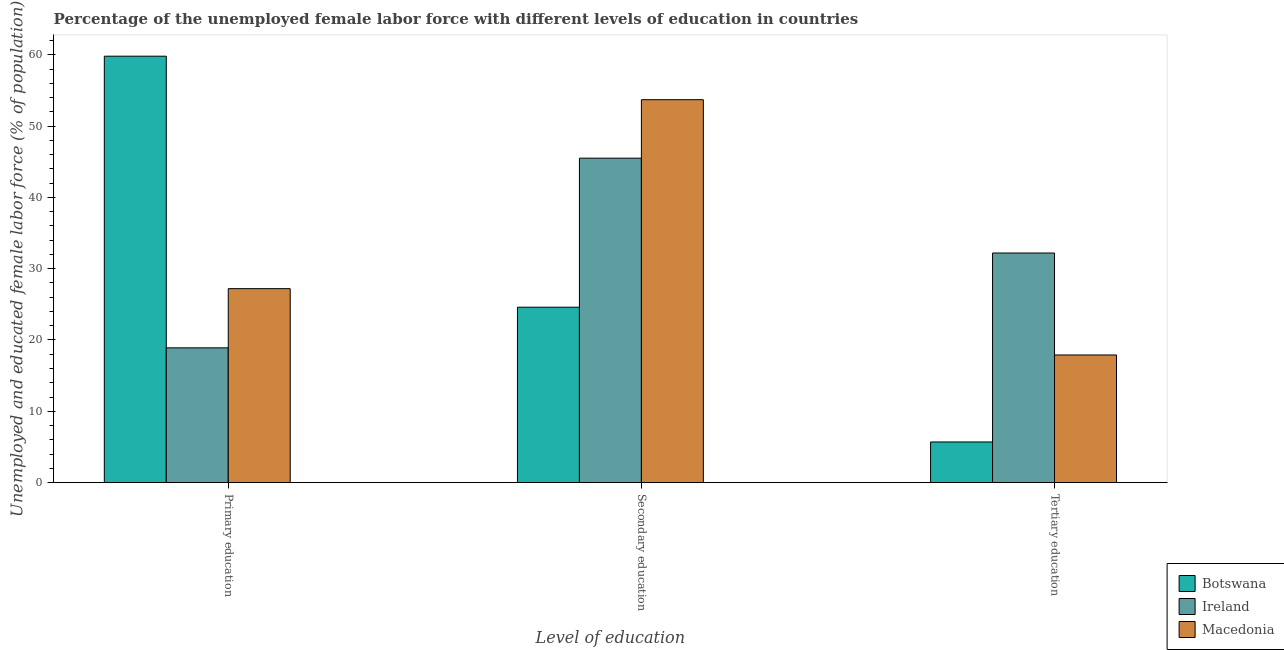How many different coloured bars are there?
Make the answer very short. 3. How many bars are there on the 3rd tick from the left?
Offer a very short reply. 3. How many bars are there on the 3rd tick from the right?
Ensure brevity in your answer.  3. What is the label of the 2nd group of bars from the left?
Offer a terse response. Secondary education. What is the percentage of female labor force who received tertiary education in Macedonia?
Ensure brevity in your answer.  17.9. Across all countries, what is the maximum percentage of female labor force who received tertiary education?
Your answer should be very brief. 32.2. Across all countries, what is the minimum percentage of female labor force who received secondary education?
Give a very brief answer. 24.6. In which country was the percentage of female labor force who received secondary education maximum?
Provide a short and direct response. Macedonia. In which country was the percentage of female labor force who received secondary education minimum?
Your answer should be compact. Botswana. What is the total percentage of female labor force who received tertiary education in the graph?
Provide a succinct answer. 55.8. What is the difference between the percentage of female labor force who received secondary education in Ireland and that in Botswana?
Make the answer very short. 20.9. What is the difference between the percentage of female labor force who received secondary education in Ireland and the percentage of female labor force who received primary education in Botswana?
Make the answer very short. -14.3. What is the average percentage of female labor force who received primary education per country?
Your response must be concise. 35.3. What is the difference between the percentage of female labor force who received primary education and percentage of female labor force who received secondary education in Botswana?
Your answer should be very brief. 35.2. What is the ratio of the percentage of female labor force who received tertiary education in Botswana to that in Ireland?
Your response must be concise. 0.18. Is the percentage of female labor force who received tertiary education in Macedonia less than that in Ireland?
Offer a terse response. Yes. Is the difference between the percentage of female labor force who received primary education in Ireland and Macedonia greater than the difference between the percentage of female labor force who received secondary education in Ireland and Macedonia?
Your answer should be very brief. No. What is the difference between the highest and the second highest percentage of female labor force who received secondary education?
Provide a short and direct response. 8.2. What is the difference between the highest and the lowest percentage of female labor force who received tertiary education?
Keep it short and to the point. 26.5. In how many countries, is the percentage of female labor force who received tertiary education greater than the average percentage of female labor force who received tertiary education taken over all countries?
Your answer should be very brief. 1. What does the 2nd bar from the left in Secondary education represents?
Provide a succinct answer. Ireland. What does the 1st bar from the right in Tertiary education represents?
Your answer should be very brief. Macedonia. Is it the case that in every country, the sum of the percentage of female labor force who received primary education and percentage of female labor force who received secondary education is greater than the percentage of female labor force who received tertiary education?
Give a very brief answer. Yes. How many bars are there?
Your answer should be compact. 9. How many countries are there in the graph?
Ensure brevity in your answer.  3. What is the difference between two consecutive major ticks on the Y-axis?
Make the answer very short. 10. Does the graph contain grids?
Provide a succinct answer. No. How many legend labels are there?
Offer a terse response. 3. What is the title of the graph?
Your answer should be very brief. Percentage of the unemployed female labor force with different levels of education in countries. What is the label or title of the X-axis?
Offer a terse response. Level of education. What is the label or title of the Y-axis?
Offer a very short reply. Unemployed and educated female labor force (% of population). What is the Unemployed and educated female labor force (% of population) in Botswana in Primary education?
Keep it short and to the point. 59.8. What is the Unemployed and educated female labor force (% of population) in Ireland in Primary education?
Keep it short and to the point. 18.9. What is the Unemployed and educated female labor force (% of population) in Macedonia in Primary education?
Ensure brevity in your answer.  27.2. What is the Unemployed and educated female labor force (% of population) of Botswana in Secondary education?
Ensure brevity in your answer.  24.6. What is the Unemployed and educated female labor force (% of population) in Ireland in Secondary education?
Make the answer very short. 45.5. What is the Unemployed and educated female labor force (% of population) in Macedonia in Secondary education?
Provide a succinct answer. 53.7. What is the Unemployed and educated female labor force (% of population) of Botswana in Tertiary education?
Offer a terse response. 5.7. What is the Unemployed and educated female labor force (% of population) in Ireland in Tertiary education?
Keep it short and to the point. 32.2. What is the Unemployed and educated female labor force (% of population) of Macedonia in Tertiary education?
Offer a very short reply. 17.9. Across all Level of education, what is the maximum Unemployed and educated female labor force (% of population) in Botswana?
Provide a succinct answer. 59.8. Across all Level of education, what is the maximum Unemployed and educated female labor force (% of population) in Ireland?
Your answer should be very brief. 45.5. Across all Level of education, what is the maximum Unemployed and educated female labor force (% of population) of Macedonia?
Provide a short and direct response. 53.7. Across all Level of education, what is the minimum Unemployed and educated female labor force (% of population) in Botswana?
Offer a very short reply. 5.7. Across all Level of education, what is the minimum Unemployed and educated female labor force (% of population) of Ireland?
Your answer should be compact. 18.9. Across all Level of education, what is the minimum Unemployed and educated female labor force (% of population) in Macedonia?
Ensure brevity in your answer.  17.9. What is the total Unemployed and educated female labor force (% of population) in Botswana in the graph?
Provide a short and direct response. 90.1. What is the total Unemployed and educated female labor force (% of population) of Ireland in the graph?
Your answer should be very brief. 96.6. What is the total Unemployed and educated female labor force (% of population) of Macedonia in the graph?
Provide a succinct answer. 98.8. What is the difference between the Unemployed and educated female labor force (% of population) of Botswana in Primary education and that in Secondary education?
Provide a short and direct response. 35.2. What is the difference between the Unemployed and educated female labor force (% of population) in Ireland in Primary education and that in Secondary education?
Ensure brevity in your answer.  -26.6. What is the difference between the Unemployed and educated female labor force (% of population) of Macedonia in Primary education and that in Secondary education?
Provide a short and direct response. -26.5. What is the difference between the Unemployed and educated female labor force (% of population) in Botswana in Primary education and that in Tertiary education?
Provide a succinct answer. 54.1. What is the difference between the Unemployed and educated female labor force (% of population) in Ireland in Primary education and that in Tertiary education?
Offer a terse response. -13.3. What is the difference between the Unemployed and educated female labor force (% of population) in Macedonia in Primary education and that in Tertiary education?
Provide a succinct answer. 9.3. What is the difference between the Unemployed and educated female labor force (% of population) in Botswana in Secondary education and that in Tertiary education?
Give a very brief answer. 18.9. What is the difference between the Unemployed and educated female labor force (% of population) of Ireland in Secondary education and that in Tertiary education?
Provide a succinct answer. 13.3. What is the difference between the Unemployed and educated female labor force (% of population) in Macedonia in Secondary education and that in Tertiary education?
Provide a short and direct response. 35.8. What is the difference between the Unemployed and educated female labor force (% of population) of Botswana in Primary education and the Unemployed and educated female labor force (% of population) of Ireland in Secondary education?
Provide a succinct answer. 14.3. What is the difference between the Unemployed and educated female labor force (% of population) in Botswana in Primary education and the Unemployed and educated female labor force (% of population) in Macedonia in Secondary education?
Offer a terse response. 6.1. What is the difference between the Unemployed and educated female labor force (% of population) in Ireland in Primary education and the Unemployed and educated female labor force (% of population) in Macedonia in Secondary education?
Offer a terse response. -34.8. What is the difference between the Unemployed and educated female labor force (% of population) of Botswana in Primary education and the Unemployed and educated female labor force (% of population) of Ireland in Tertiary education?
Provide a short and direct response. 27.6. What is the difference between the Unemployed and educated female labor force (% of population) in Botswana in Primary education and the Unemployed and educated female labor force (% of population) in Macedonia in Tertiary education?
Give a very brief answer. 41.9. What is the difference between the Unemployed and educated female labor force (% of population) of Botswana in Secondary education and the Unemployed and educated female labor force (% of population) of Ireland in Tertiary education?
Provide a short and direct response. -7.6. What is the difference between the Unemployed and educated female labor force (% of population) of Botswana in Secondary education and the Unemployed and educated female labor force (% of population) of Macedonia in Tertiary education?
Your response must be concise. 6.7. What is the difference between the Unemployed and educated female labor force (% of population) of Ireland in Secondary education and the Unemployed and educated female labor force (% of population) of Macedonia in Tertiary education?
Your response must be concise. 27.6. What is the average Unemployed and educated female labor force (% of population) in Botswana per Level of education?
Give a very brief answer. 30.03. What is the average Unemployed and educated female labor force (% of population) in Ireland per Level of education?
Keep it short and to the point. 32.2. What is the average Unemployed and educated female labor force (% of population) in Macedonia per Level of education?
Give a very brief answer. 32.93. What is the difference between the Unemployed and educated female labor force (% of population) in Botswana and Unemployed and educated female labor force (% of population) in Ireland in Primary education?
Provide a short and direct response. 40.9. What is the difference between the Unemployed and educated female labor force (% of population) in Botswana and Unemployed and educated female labor force (% of population) in Macedonia in Primary education?
Make the answer very short. 32.6. What is the difference between the Unemployed and educated female labor force (% of population) of Botswana and Unemployed and educated female labor force (% of population) of Ireland in Secondary education?
Your answer should be very brief. -20.9. What is the difference between the Unemployed and educated female labor force (% of population) in Botswana and Unemployed and educated female labor force (% of population) in Macedonia in Secondary education?
Your response must be concise. -29.1. What is the difference between the Unemployed and educated female labor force (% of population) of Botswana and Unemployed and educated female labor force (% of population) of Ireland in Tertiary education?
Offer a terse response. -26.5. What is the ratio of the Unemployed and educated female labor force (% of population) in Botswana in Primary education to that in Secondary education?
Make the answer very short. 2.43. What is the ratio of the Unemployed and educated female labor force (% of population) of Ireland in Primary education to that in Secondary education?
Provide a short and direct response. 0.42. What is the ratio of the Unemployed and educated female labor force (% of population) of Macedonia in Primary education to that in Secondary education?
Provide a short and direct response. 0.51. What is the ratio of the Unemployed and educated female labor force (% of population) of Botswana in Primary education to that in Tertiary education?
Provide a short and direct response. 10.49. What is the ratio of the Unemployed and educated female labor force (% of population) in Ireland in Primary education to that in Tertiary education?
Offer a very short reply. 0.59. What is the ratio of the Unemployed and educated female labor force (% of population) in Macedonia in Primary education to that in Tertiary education?
Keep it short and to the point. 1.52. What is the ratio of the Unemployed and educated female labor force (% of population) of Botswana in Secondary education to that in Tertiary education?
Offer a terse response. 4.32. What is the ratio of the Unemployed and educated female labor force (% of population) in Ireland in Secondary education to that in Tertiary education?
Provide a short and direct response. 1.41. What is the ratio of the Unemployed and educated female labor force (% of population) in Macedonia in Secondary education to that in Tertiary education?
Make the answer very short. 3. What is the difference between the highest and the second highest Unemployed and educated female labor force (% of population) in Botswana?
Offer a very short reply. 35.2. What is the difference between the highest and the lowest Unemployed and educated female labor force (% of population) in Botswana?
Provide a short and direct response. 54.1. What is the difference between the highest and the lowest Unemployed and educated female labor force (% of population) of Ireland?
Keep it short and to the point. 26.6. What is the difference between the highest and the lowest Unemployed and educated female labor force (% of population) of Macedonia?
Offer a terse response. 35.8. 